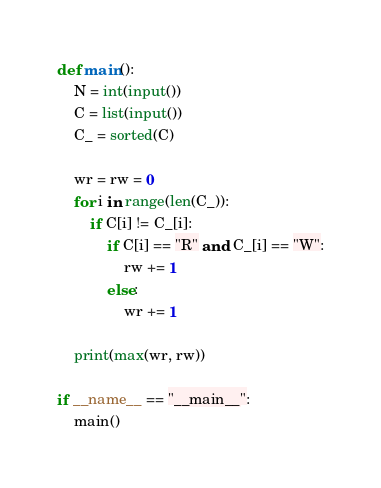<code> <loc_0><loc_0><loc_500><loc_500><_Python_>def main():
    N = int(input())
    C = list(input())
    C_ = sorted(C)

    wr = rw = 0
    for i in range(len(C_)):
        if C[i] != C_[i]:
            if C[i] == "R" and C_[i] == "W":
                rw += 1
            else:
                wr += 1

    print(max(wr, rw))
    
if __name__ == "__main__":
    main()</code> 